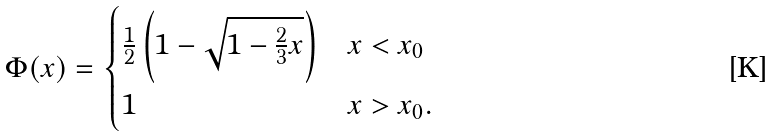<formula> <loc_0><loc_0><loc_500><loc_500>\Phi ( x ) = \begin{cases} \frac { 1 } { 2 } \left ( 1 - \sqrt { 1 - \frac { 2 } { 3 } x } \right ) & x < x _ { 0 } \\ 1 & x > x _ { 0 } . \\ \end{cases}</formula> 